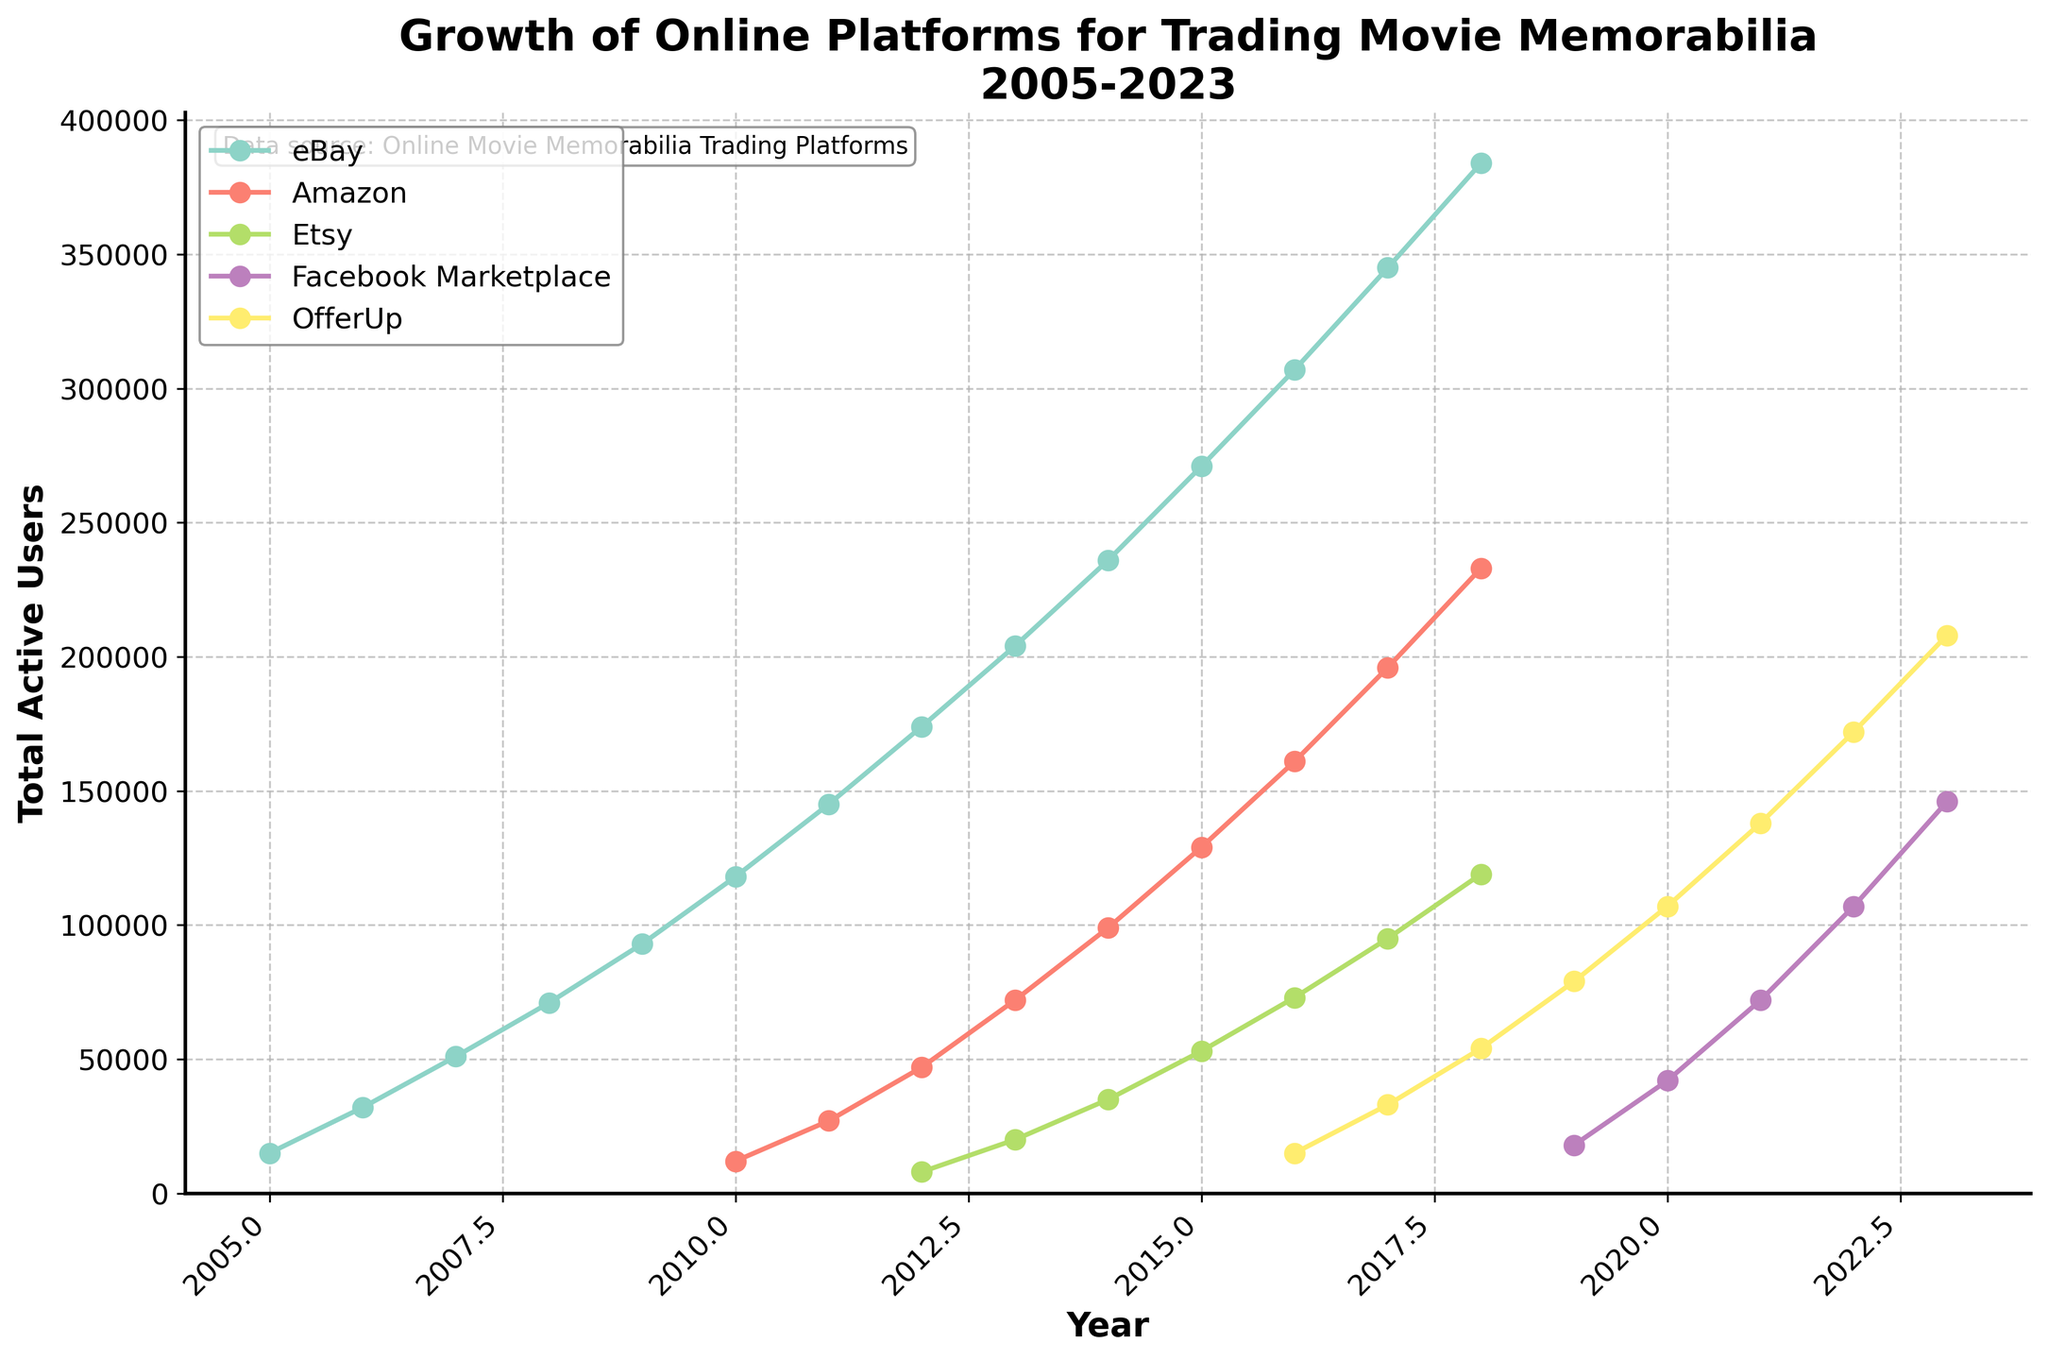What is the time range depicted in the plot? The x-axis represents the years, which range from 2005 to 2023.
Answer: 2005 to 2023 Which platform had the highest number of total active users in 2023? In the plot, at the year 2023, Facebook Marketplace shows the highest value of total active users compared to other platforms.
Answer: Facebook Marketplace By how many users did OfferUp's total active users increase from 2016 to 2023? OfferUp had 15000 total active users in 2016 and 208000 in 2023. Subtracting these gives 208000 - 15000 = 193000.
Answer: 193000 Which platform had a steeper growth in total active users between 2016 and 2023: Etsy or OfferUp? From 2016 to 2023, OfferUp increased from 15000 to 208000 users, while Etsy increased from 73000 to 119000 users. OfferUp's increase is 208000 - 15000 = 193000, and Etsy's increase is 119000 - 73000 = 46000. OfferUp had a steeper growth.
Answer: OfferUp What was the trend of total active users for eBay from 2005 to 2018? The total active users for eBay increased steadily from 15000 in 2005 to 384000 in 2018, showing consistent growth each year.
Answer: Steady increase How does the total active users of Amazon in 2016 compare to those of Facebook Marketplace in 2021? Amazon had 161000 total active users in 2016, while Facebook Marketplace had 72000 total active users in 2021. Thus, Amazon had more users in 2016 than Facebook Marketplace had in 2021.
Answer: Amazon had more Which year did Amazon overtake eBay in terms of total active users? By examining the plot, Amazon never overtakes eBay in total active users throughout the depicted years.
Answer: Never Was there any platform that demonstrated a decline in total active users on the plot? The plot shows that all platforms had an increasing trend in total active users; none of the platforms displayed a decline.
Answer: No How many platforms were included in the plot, and what are their names? The legend shows 5 different colors representing the platforms: eBay, Amazon, Etsy, Facebook Marketplace, and OfferUp.
Answer: 5; eBay, Amazon, Etsy, Facebook Marketplace, OfferUp 